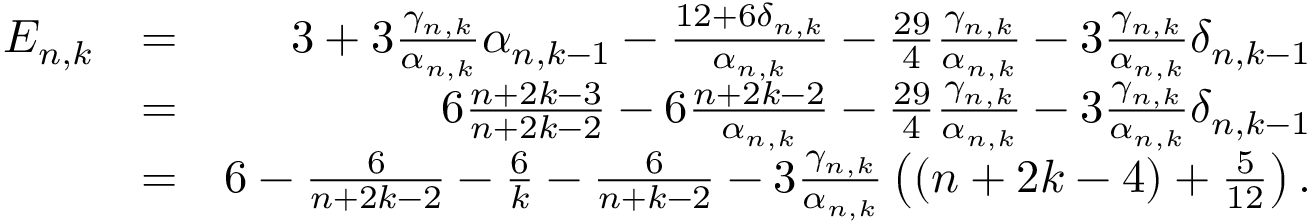Convert formula to latex. <formula><loc_0><loc_0><loc_500><loc_500>\begin{array} { r l r } { E _ { n , k } } & { = } & { 3 + 3 \frac { \gamma _ { n , k } } { \alpha _ { n , k } } \alpha _ { n , k - 1 } - \frac { 1 2 + 6 \delta _ { n , k } } { \alpha _ { n , k } } - \frac { 2 9 } { 4 } \frac { \gamma _ { n , k } } { \alpha _ { n , k } } - 3 \frac { \gamma _ { n , k } } { \alpha _ { n , k } } \delta _ { n , k - 1 } } \\ & { = } & { 6 \frac { n + 2 k - 3 } { n + 2 k - 2 } - 6 \frac { n + 2 k - 2 } { \alpha _ { n , k } } - \frac { 2 9 } { 4 } \frac { \gamma _ { n , k } } { \alpha _ { n , k } } - 3 \frac { \gamma _ { n , k } } { \alpha _ { n , k } } \delta _ { n , k - 1 } } \\ & { = } & { 6 - \frac { 6 } n + 2 k - 2 } - \frac { 6 } { k } - \frac { 6 } n + k - 2 } - 3 \frac { \gamma _ { n , k } } { \alpha _ { n , k } } \left ( ( n + 2 k - 4 ) + \frac { 5 } 1 2 } \right ) . } \end{array}</formula> 